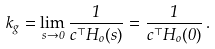Convert formula to latex. <formula><loc_0><loc_0><loc_500><loc_500>k _ { g } = \lim _ { s \rightarrow 0 } \frac { 1 } { c ^ { \top } H _ { o } ( s ) } = \frac { 1 } { c ^ { \top } H _ { o } ( 0 ) } \, .</formula> 